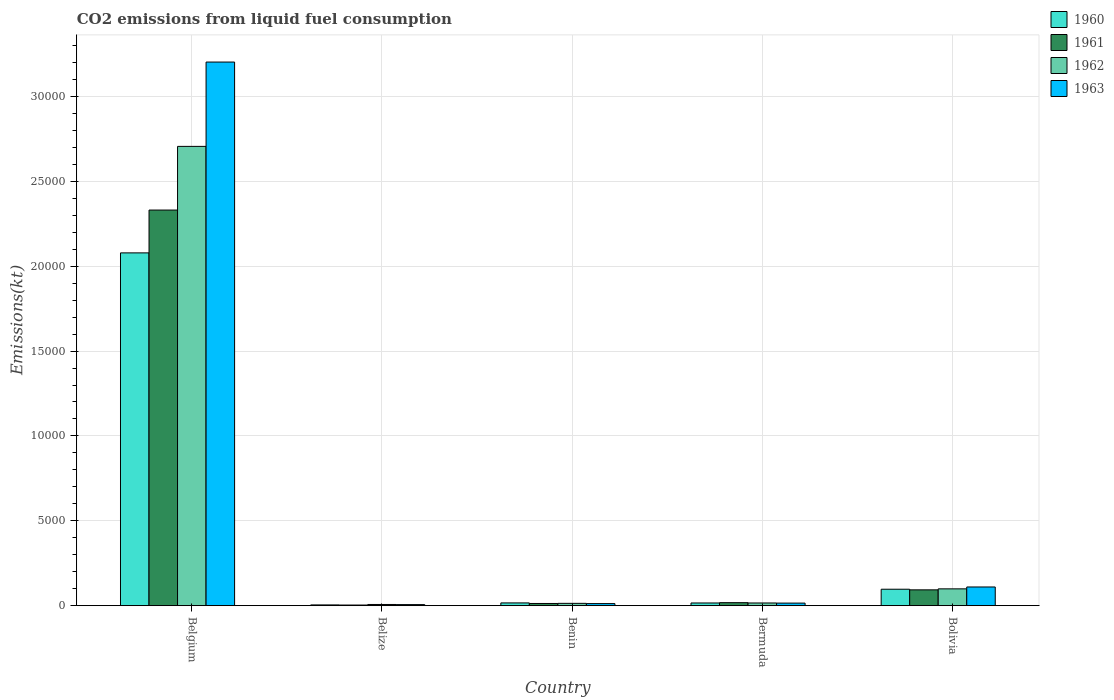Are the number of bars per tick equal to the number of legend labels?
Provide a short and direct response. Yes. Are the number of bars on each tick of the X-axis equal?
Your answer should be very brief. Yes. How many bars are there on the 4th tick from the left?
Ensure brevity in your answer.  4. What is the label of the 4th group of bars from the left?
Offer a terse response. Bermuda. In how many cases, is the number of bars for a given country not equal to the number of legend labels?
Give a very brief answer. 0. What is the amount of CO2 emitted in 1963 in Belgium?
Provide a short and direct response. 3.20e+04. Across all countries, what is the maximum amount of CO2 emitted in 1963?
Keep it short and to the point. 3.20e+04. Across all countries, what is the minimum amount of CO2 emitted in 1961?
Provide a short and direct response. 36.67. In which country was the amount of CO2 emitted in 1961 minimum?
Provide a short and direct response. Belize. What is the total amount of CO2 emitted in 1962 in the graph?
Offer a very short reply. 2.84e+04. What is the difference between the amount of CO2 emitted in 1962 in Belize and that in Bermuda?
Offer a very short reply. -88.01. What is the difference between the amount of CO2 emitted in 1960 in Belize and the amount of CO2 emitted in 1962 in Bolivia?
Make the answer very short. -946.09. What is the average amount of CO2 emitted in 1960 per country?
Provide a short and direct response. 4423.14. What is the difference between the amount of CO2 emitted of/in 1961 and amount of CO2 emitted of/in 1963 in Benin?
Provide a short and direct response. 7.33. In how many countries, is the amount of CO2 emitted in 1962 greater than 12000 kt?
Make the answer very short. 1. What is the ratio of the amount of CO2 emitted in 1961 in Benin to that in Bermuda?
Give a very brief answer. 0.73. Is the amount of CO2 emitted in 1960 in Belgium less than that in Benin?
Provide a short and direct response. No. Is the difference between the amount of CO2 emitted in 1961 in Belgium and Belize greater than the difference between the amount of CO2 emitted in 1963 in Belgium and Belize?
Your answer should be very brief. No. What is the difference between the highest and the second highest amount of CO2 emitted in 1960?
Keep it short and to the point. 2.06e+04. What is the difference between the highest and the lowest amount of CO2 emitted in 1962?
Your response must be concise. 2.70e+04. In how many countries, is the amount of CO2 emitted in 1961 greater than the average amount of CO2 emitted in 1961 taken over all countries?
Keep it short and to the point. 1. What does the 2nd bar from the right in Benin represents?
Make the answer very short. 1962. Is it the case that in every country, the sum of the amount of CO2 emitted in 1961 and amount of CO2 emitted in 1962 is greater than the amount of CO2 emitted in 1963?
Your answer should be compact. Yes. How many bars are there?
Offer a very short reply. 20. Does the graph contain any zero values?
Make the answer very short. No. Does the graph contain grids?
Your answer should be compact. Yes. Where does the legend appear in the graph?
Offer a very short reply. Top right. How many legend labels are there?
Your response must be concise. 4. How are the legend labels stacked?
Offer a very short reply. Vertical. What is the title of the graph?
Give a very brief answer. CO2 emissions from liquid fuel consumption. Does "1973" appear as one of the legend labels in the graph?
Your answer should be compact. No. What is the label or title of the X-axis?
Provide a succinct answer. Country. What is the label or title of the Y-axis?
Give a very brief answer. Emissions(kt). What is the Emissions(kt) in 1960 in Belgium?
Offer a very short reply. 2.08e+04. What is the Emissions(kt) in 1961 in Belgium?
Your response must be concise. 2.33e+04. What is the Emissions(kt) of 1962 in Belgium?
Your answer should be very brief. 2.71e+04. What is the Emissions(kt) in 1963 in Belgium?
Your answer should be very brief. 3.20e+04. What is the Emissions(kt) in 1960 in Belize?
Keep it short and to the point. 44. What is the Emissions(kt) of 1961 in Belize?
Make the answer very short. 36.67. What is the Emissions(kt) in 1962 in Belize?
Make the answer very short. 69.67. What is the Emissions(kt) in 1963 in Belize?
Offer a terse response. 62.34. What is the Emissions(kt) of 1960 in Benin?
Offer a terse response. 161.35. What is the Emissions(kt) of 1961 in Benin?
Provide a succinct answer. 128.34. What is the Emissions(kt) of 1962 in Benin?
Offer a very short reply. 135.68. What is the Emissions(kt) in 1963 in Benin?
Your response must be concise. 121.01. What is the Emissions(kt) of 1960 in Bermuda?
Your answer should be very brief. 157.68. What is the Emissions(kt) of 1961 in Bermuda?
Offer a very short reply. 176.02. What is the Emissions(kt) of 1962 in Bermuda?
Your answer should be compact. 157.68. What is the Emissions(kt) of 1963 in Bermuda?
Ensure brevity in your answer.  150.35. What is the Emissions(kt) in 1960 in Bolivia?
Give a very brief answer. 968.09. What is the Emissions(kt) in 1961 in Bolivia?
Offer a very short reply. 931.42. What is the Emissions(kt) in 1962 in Bolivia?
Your response must be concise. 990.09. What is the Emissions(kt) of 1963 in Bolivia?
Provide a short and direct response. 1100.1. Across all countries, what is the maximum Emissions(kt) of 1960?
Ensure brevity in your answer.  2.08e+04. Across all countries, what is the maximum Emissions(kt) of 1961?
Your answer should be compact. 2.33e+04. Across all countries, what is the maximum Emissions(kt) in 1962?
Give a very brief answer. 2.71e+04. Across all countries, what is the maximum Emissions(kt) in 1963?
Offer a very short reply. 3.20e+04. Across all countries, what is the minimum Emissions(kt) in 1960?
Offer a terse response. 44. Across all countries, what is the minimum Emissions(kt) in 1961?
Offer a very short reply. 36.67. Across all countries, what is the minimum Emissions(kt) in 1962?
Offer a terse response. 69.67. Across all countries, what is the minimum Emissions(kt) of 1963?
Your response must be concise. 62.34. What is the total Emissions(kt) in 1960 in the graph?
Your answer should be compact. 2.21e+04. What is the total Emissions(kt) of 1961 in the graph?
Keep it short and to the point. 2.46e+04. What is the total Emissions(kt) of 1962 in the graph?
Offer a terse response. 2.84e+04. What is the total Emissions(kt) in 1963 in the graph?
Your response must be concise. 3.35e+04. What is the difference between the Emissions(kt) in 1960 in Belgium and that in Belize?
Your response must be concise. 2.07e+04. What is the difference between the Emissions(kt) of 1961 in Belgium and that in Belize?
Your answer should be compact. 2.33e+04. What is the difference between the Emissions(kt) in 1962 in Belgium and that in Belize?
Ensure brevity in your answer.  2.70e+04. What is the difference between the Emissions(kt) in 1963 in Belgium and that in Belize?
Your answer should be very brief. 3.20e+04. What is the difference between the Emissions(kt) of 1960 in Belgium and that in Benin?
Give a very brief answer. 2.06e+04. What is the difference between the Emissions(kt) of 1961 in Belgium and that in Benin?
Offer a very short reply. 2.32e+04. What is the difference between the Emissions(kt) in 1962 in Belgium and that in Benin?
Your response must be concise. 2.69e+04. What is the difference between the Emissions(kt) in 1963 in Belgium and that in Benin?
Provide a succinct answer. 3.19e+04. What is the difference between the Emissions(kt) of 1960 in Belgium and that in Bermuda?
Make the answer very short. 2.06e+04. What is the difference between the Emissions(kt) of 1961 in Belgium and that in Bermuda?
Provide a short and direct response. 2.31e+04. What is the difference between the Emissions(kt) of 1962 in Belgium and that in Bermuda?
Your answer should be very brief. 2.69e+04. What is the difference between the Emissions(kt) of 1963 in Belgium and that in Bermuda?
Your response must be concise. 3.19e+04. What is the difference between the Emissions(kt) of 1960 in Belgium and that in Bolivia?
Provide a succinct answer. 1.98e+04. What is the difference between the Emissions(kt) of 1961 in Belgium and that in Bolivia?
Provide a short and direct response. 2.24e+04. What is the difference between the Emissions(kt) in 1962 in Belgium and that in Bolivia?
Your answer should be very brief. 2.61e+04. What is the difference between the Emissions(kt) of 1963 in Belgium and that in Bolivia?
Provide a succinct answer. 3.09e+04. What is the difference between the Emissions(kt) in 1960 in Belize and that in Benin?
Offer a very short reply. -117.34. What is the difference between the Emissions(kt) in 1961 in Belize and that in Benin?
Your answer should be compact. -91.67. What is the difference between the Emissions(kt) of 1962 in Belize and that in Benin?
Offer a terse response. -66.01. What is the difference between the Emissions(kt) in 1963 in Belize and that in Benin?
Give a very brief answer. -58.67. What is the difference between the Emissions(kt) of 1960 in Belize and that in Bermuda?
Offer a terse response. -113.68. What is the difference between the Emissions(kt) of 1961 in Belize and that in Bermuda?
Provide a succinct answer. -139.35. What is the difference between the Emissions(kt) in 1962 in Belize and that in Bermuda?
Ensure brevity in your answer.  -88.01. What is the difference between the Emissions(kt) of 1963 in Belize and that in Bermuda?
Provide a succinct answer. -88.01. What is the difference between the Emissions(kt) of 1960 in Belize and that in Bolivia?
Provide a short and direct response. -924.08. What is the difference between the Emissions(kt) in 1961 in Belize and that in Bolivia?
Give a very brief answer. -894.75. What is the difference between the Emissions(kt) of 1962 in Belize and that in Bolivia?
Ensure brevity in your answer.  -920.42. What is the difference between the Emissions(kt) of 1963 in Belize and that in Bolivia?
Ensure brevity in your answer.  -1037.76. What is the difference between the Emissions(kt) in 1960 in Benin and that in Bermuda?
Your answer should be compact. 3.67. What is the difference between the Emissions(kt) of 1961 in Benin and that in Bermuda?
Give a very brief answer. -47.67. What is the difference between the Emissions(kt) in 1962 in Benin and that in Bermuda?
Your answer should be very brief. -22. What is the difference between the Emissions(kt) of 1963 in Benin and that in Bermuda?
Provide a short and direct response. -29.34. What is the difference between the Emissions(kt) of 1960 in Benin and that in Bolivia?
Offer a terse response. -806.74. What is the difference between the Emissions(kt) of 1961 in Benin and that in Bolivia?
Give a very brief answer. -803.07. What is the difference between the Emissions(kt) in 1962 in Benin and that in Bolivia?
Make the answer very short. -854.41. What is the difference between the Emissions(kt) of 1963 in Benin and that in Bolivia?
Your response must be concise. -979.09. What is the difference between the Emissions(kt) of 1960 in Bermuda and that in Bolivia?
Keep it short and to the point. -810.41. What is the difference between the Emissions(kt) in 1961 in Bermuda and that in Bolivia?
Your response must be concise. -755.4. What is the difference between the Emissions(kt) in 1962 in Bermuda and that in Bolivia?
Your answer should be compact. -832.41. What is the difference between the Emissions(kt) of 1963 in Bermuda and that in Bolivia?
Provide a succinct answer. -949.75. What is the difference between the Emissions(kt) of 1960 in Belgium and the Emissions(kt) of 1961 in Belize?
Provide a short and direct response. 2.07e+04. What is the difference between the Emissions(kt) in 1960 in Belgium and the Emissions(kt) in 1962 in Belize?
Offer a terse response. 2.07e+04. What is the difference between the Emissions(kt) of 1960 in Belgium and the Emissions(kt) of 1963 in Belize?
Give a very brief answer. 2.07e+04. What is the difference between the Emissions(kt) in 1961 in Belgium and the Emissions(kt) in 1962 in Belize?
Offer a very short reply. 2.32e+04. What is the difference between the Emissions(kt) in 1961 in Belgium and the Emissions(kt) in 1963 in Belize?
Ensure brevity in your answer.  2.32e+04. What is the difference between the Emissions(kt) of 1962 in Belgium and the Emissions(kt) of 1963 in Belize?
Your answer should be very brief. 2.70e+04. What is the difference between the Emissions(kt) of 1960 in Belgium and the Emissions(kt) of 1961 in Benin?
Offer a very short reply. 2.07e+04. What is the difference between the Emissions(kt) of 1960 in Belgium and the Emissions(kt) of 1962 in Benin?
Your answer should be compact. 2.06e+04. What is the difference between the Emissions(kt) in 1960 in Belgium and the Emissions(kt) in 1963 in Benin?
Ensure brevity in your answer.  2.07e+04. What is the difference between the Emissions(kt) of 1961 in Belgium and the Emissions(kt) of 1962 in Benin?
Your answer should be compact. 2.32e+04. What is the difference between the Emissions(kt) in 1961 in Belgium and the Emissions(kt) in 1963 in Benin?
Give a very brief answer. 2.32e+04. What is the difference between the Emissions(kt) in 1962 in Belgium and the Emissions(kt) in 1963 in Benin?
Provide a succinct answer. 2.69e+04. What is the difference between the Emissions(kt) in 1960 in Belgium and the Emissions(kt) in 1961 in Bermuda?
Provide a short and direct response. 2.06e+04. What is the difference between the Emissions(kt) in 1960 in Belgium and the Emissions(kt) in 1962 in Bermuda?
Provide a short and direct response. 2.06e+04. What is the difference between the Emissions(kt) of 1960 in Belgium and the Emissions(kt) of 1963 in Bermuda?
Provide a short and direct response. 2.06e+04. What is the difference between the Emissions(kt) of 1961 in Belgium and the Emissions(kt) of 1962 in Bermuda?
Your response must be concise. 2.31e+04. What is the difference between the Emissions(kt) in 1961 in Belgium and the Emissions(kt) in 1963 in Bermuda?
Your answer should be compact. 2.32e+04. What is the difference between the Emissions(kt) of 1962 in Belgium and the Emissions(kt) of 1963 in Bermuda?
Keep it short and to the point. 2.69e+04. What is the difference between the Emissions(kt) of 1960 in Belgium and the Emissions(kt) of 1961 in Bolivia?
Provide a short and direct response. 1.99e+04. What is the difference between the Emissions(kt) in 1960 in Belgium and the Emissions(kt) in 1962 in Bolivia?
Provide a succinct answer. 1.98e+04. What is the difference between the Emissions(kt) of 1960 in Belgium and the Emissions(kt) of 1963 in Bolivia?
Provide a short and direct response. 1.97e+04. What is the difference between the Emissions(kt) of 1961 in Belgium and the Emissions(kt) of 1962 in Bolivia?
Keep it short and to the point. 2.23e+04. What is the difference between the Emissions(kt) in 1961 in Belgium and the Emissions(kt) in 1963 in Bolivia?
Ensure brevity in your answer.  2.22e+04. What is the difference between the Emissions(kt) in 1962 in Belgium and the Emissions(kt) in 1963 in Bolivia?
Keep it short and to the point. 2.60e+04. What is the difference between the Emissions(kt) in 1960 in Belize and the Emissions(kt) in 1961 in Benin?
Offer a very short reply. -84.34. What is the difference between the Emissions(kt) in 1960 in Belize and the Emissions(kt) in 1962 in Benin?
Your answer should be very brief. -91.67. What is the difference between the Emissions(kt) in 1960 in Belize and the Emissions(kt) in 1963 in Benin?
Your response must be concise. -77.01. What is the difference between the Emissions(kt) of 1961 in Belize and the Emissions(kt) of 1962 in Benin?
Make the answer very short. -99.01. What is the difference between the Emissions(kt) of 1961 in Belize and the Emissions(kt) of 1963 in Benin?
Make the answer very short. -84.34. What is the difference between the Emissions(kt) of 1962 in Belize and the Emissions(kt) of 1963 in Benin?
Your response must be concise. -51.34. What is the difference between the Emissions(kt) of 1960 in Belize and the Emissions(kt) of 1961 in Bermuda?
Make the answer very short. -132.01. What is the difference between the Emissions(kt) of 1960 in Belize and the Emissions(kt) of 1962 in Bermuda?
Provide a short and direct response. -113.68. What is the difference between the Emissions(kt) in 1960 in Belize and the Emissions(kt) in 1963 in Bermuda?
Ensure brevity in your answer.  -106.34. What is the difference between the Emissions(kt) of 1961 in Belize and the Emissions(kt) of 1962 in Bermuda?
Make the answer very short. -121.01. What is the difference between the Emissions(kt) in 1961 in Belize and the Emissions(kt) in 1963 in Bermuda?
Offer a very short reply. -113.68. What is the difference between the Emissions(kt) of 1962 in Belize and the Emissions(kt) of 1963 in Bermuda?
Ensure brevity in your answer.  -80.67. What is the difference between the Emissions(kt) in 1960 in Belize and the Emissions(kt) in 1961 in Bolivia?
Make the answer very short. -887.41. What is the difference between the Emissions(kt) in 1960 in Belize and the Emissions(kt) in 1962 in Bolivia?
Provide a succinct answer. -946.09. What is the difference between the Emissions(kt) of 1960 in Belize and the Emissions(kt) of 1963 in Bolivia?
Provide a short and direct response. -1056.1. What is the difference between the Emissions(kt) of 1961 in Belize and the Emissions(kt) of 1962 in Bolivia?
Make the answer very short. -953.42. What is the difference between the Emissions(kt) of 1961 in Belize and the Emissions(kt) of 1963 in Bolivia?
Your answer should be very brief. -1063.43. What is the difference between the Emissions(kt) in 1962 in Belize and the Emissions(kt) in 1963 in Bolivia?
Your response must be concise. -1030.43. What is the difference between the Emissions(kt) in 1960 in Benin and the Emissions(kt) in 1961 in Bermuda?
Give a very brief answer. -14.67. What is the difference between the Emissions(kt) in 1960 in Benin and the Emissions(kt) in 1962 in Bermuda?
Give a very brief answer. 3.67. What is the difference between the Emissions(kt) in 1960 in Benin and the Emissions(kt) in 1963 in Bermuda?
Ensure brevity in your answer.  11. What is the difference between the Emissions(kt) of 1961 in Benin and the Emissions(kt) of 1962 in Bermuda?
Your answer should be compact. -29.34. What is the difference between the Emissions(kt) in 1961 in Benin and the Emissions(kt) in 1963 in Bermuda?
Make the answer very short. -22. What is the difference between the Emissions(kt) of 1962 in Benin and the Emissions(kt) of 1963 in Bermuda?
Provide a succinct answer. -14.67. What is the difference between the Emissions(kt) in 1960 in Benin and the Emissions(kt) in 1961 in Bolivia?
Provide a succinct answer. -770.07. What is the difference between the Emissions(kt) in 1960 in Benin and the Emissions(kt) in 1962 in Bolivia?
Provide a succinct answer. -828.74. What is the difference between the Emissions(kt) of 1960 in Benin and the Emissions(kt) of 1963 in Bolivia?
Ensure brevity in your answer.  -938.75. What is the difference between the Emissions(kt) of 1961 in Benin and the Emissions(kt) of 1962 in Bolivia?
Your answer should be compact. -861.75. What is the difference between the Emissions(kt) of 1961 in Benin and the Emissions(kt) of 1963 in Bolivia?
Offer a very short reply. -971.75. What is the difference between the Emissions(kt) of 1962 in Benin and the Emissions(kt) of 1963 in Bolivia?
Ensure brevity in your answer.  -964.42. What is the difference between the Emissions(kt) of 1960 in Bermuda and the Emissions(kt) of 1961 in Bolivia?
Your answer should be compact. -773.74. What is the difference between the Emissions(kt) of 1960 in Bermuda and the Emissions(kt) of 1962 in Bolivia?
Give a very brief answer. -832.41. What is the difference between the Emissions(kt) in 1960 in Bermuda and the Emissions(kt) in 1963 in Bolivia?
Offer a very short reply. -942.42. What is the difference between the Emissions(kt) of 1961 in Bermuda and the Emissions(kt) of 1962 in Bolivia?
Offer a very short reply. -814.07. What is the difference between the Emissions(kt) in 1961 in Bermuda and the Emissions(kt) in 1963 in Bolivia?
Your answer should be compact. -924.08. What is the difference between the Emissions(kt) of 1962 in Bermuda and the Emissions(kt) of 1963 in Bolivia?
Ensure brevity in your answer.  -942.42. What is the average Emissions(kt) of 1960 per country?
Provide a short and direct response. 4423.14. What is the average Emissions(kt) in 1961 per country?
Your response must be concise. 4915.98. What is the average Emissions(kt) in 1962 per country?
Keep it short and to the point. 5682.38. What is the average Emissions(kt) of 1963 per country?
Provide a short and direct response. 6692.27. What is the difference between the Emissions(kt) in 1960 and Emissions(kt) in 1961 in Belgium?
Make the answer very short. -2522.9. What is the difference between the Emissions(kt) in 1960 and Emissions(kt) in 1962 in Belgium?
Make the answer very short. -6274.24. What is the difference between the Emissions(kt) of 1960 and Emissions(kt) of 1963 in Belgium?
Ensure brevity in your answer.  -1.12e+04. What is the difference between the Emissions(kt) of 1961 and Emissions(kt) of 1962 in Belgium?
Provide a succinct answer. -3751.34. What is the difference between the Emissions(kt) in 1961 and Emissions(kt) in 1963 in Belgium?
Provide a succinct answer. -8720.13. What is the difference between the Emissions(kt) of 1962 and Emissions(kt) of 1963 in Belgium?
Keep it short and to the point. -4968.78. What is the difference between the Emissions(kt) of 1960 and Emissions(kt) of 1961 in Belize?
Provide a succinct answer. 7.33. What is the difference between the Emissions(kt) in 1960 and Emissions(kt) in 1962 in Belize?
Ensure brevity in your answer.  -25.67. What is the difference between the Emissions(kt) of 1960 and Emissions(kt) of 1963 in Belize?
Give a very brief answer. -18.34. What is the difference between the Emissions(kt) of 1961 and Emissions(kt) of 1962 in Belize?
Ensure brevity in your answer.  -33. What is the difference between the Emissions(kt) in 1961 and Emissions(kt) in 1963 in Belize?
Your answer should be very brief. -25.67. What is the difference between the Emissions(kt) of 1962 and Emissions(kt) of 1963 in Belize?
Make the answer very short. 7.33. What is the difference between the Emissions(kt) of 1960 and Emissions(kt) of 1961 in Benin?
Your answer should be very brief. 33. What is the difference between the Emissions(kt) of 1960 and Emissions(kt) of 1962 in Benin?
Your response must be concise. 25.67. What is the difference between the Emissions(kt) in 1960 and Emissions(kt) in 1963 in Benin?
Provide a succinct answer. 40.34. What is the difference between the Emissions(kt) of 1961 and Emissions(kt) of 1962 in Benin?
Your answer should be very brief. -7.33. What is the difference between the Emissions(kt) of 1961 and Emissions(kt) of 1963 in Benin?
Ensure brevity in your answer.  7.33. What is the difference between the Emissions(kt) in 1962 and Emissions(kt) in 1963 in Benin?
Ensure brevity in your answer.  14.67. What is the difference between the Emissions(kt) of 1960 and Emissions(kt) of 1961 in Bermuda?
Offer a terse response. -18.34. What is the difference between the Emissions(kt) of 1960 and Emissions(kt) of 1962 in Bermuda?
Your response must be concise. 0. What is the difference between the Emissions(kt) of 1960 and Emissions(kt) of 1963 in Bermuda?
Offer a very short reply. 7.33. What is the difference between the Emissions(kt) in 1961 and Emissions(kt) in 1962 in Bermuda?
Your response must be concise. 18.34. What is the difference between the Emissions(kt) of 1961 and Emissions(kt) of 1963 in Bermuda?
Your response must be concise. 25.67. What is the difference between the Emissions(kt) of 1962 and Emissions(kt) of 1963 in Bermuda?
Provide a short and direct response. 7.33. What is the difference between the Emissions(kt) in 1960 and Emissions(kt) in 1961 in Bolivia?
Offer a terse response. 36.67. What is the difference between the Emissions(kt) of 1960 and Emissions(kt) of 1962 in Bolivia?
Keep it short and to the point. -22. What is the difference between the Emissions(kt) in 1960 and Emissions(kt) in 1963 in Bolivia?
Ensure brevity in your answer.  -132.01. What is the difference between the Emissions(kt) of 1961 and Emissions(kt) of 1962 in Bolivia?
Ensure brevity in your answer.  -58.67. What is the difference between the Emissions(kt) in 1961 and Emissions(kt) in 1963 in Bolivia?
Provide a succinct answer. -168.68. What is the difference between the Emissions(kt) of 1962 and Emissions(kt) of 1963 in Bolivia?
Your response must be concise. -110.01. What is the ratio of the Emissions(kt) in 1960 in Belgium to that in Belize?
Your response must be concise. 472.33. What is the ratio of the Emissions(kt) of 1961 in Belgium to that in Belize?
Provide a short and direct response. 635.6. What is the ratio of the Emissions(kt) of 1962 in Belgium to that in Belize?
Make the answer very short. 388.37. What is the ratio of the Emissions(kt) of 1963 in Belgium to that in Belize?
Your answer should be very brief. 513.76. What is the ratio of the Emissions(kt) in 1960 in Belgium to that in Benin?
Keep it short and to the point. 128.82. What is the ratio of the Emissions(kt) in 1961 in Belgium to that in Benin?
Your response must be concise. 181.6. What is the ratio of the Emissions(kt) of 1962 in Belgium to that in Benin?
Your response must be concise. 199.43. What is the ratio of the Emissions(kt) of 1963 in Belgium to that in Benin?
Provide a succinct answer. 264.67. What is the ratio of the Emissions(kt) of 1960 in Belgium to that in Bermuda?
Make the answer very short. 131.81. What is the ratio of the Emissions(kt) in 1961 in Belgium to that in Bermuda?
Make the answer very short. 132.42. What is the ratio of the Emissions(kt) in 1962 in Belgium to that in Bermuda?
Offer a very short reply. 171.6. What is the ratio of the Emissions(kt) of 1963 in Belgium to that in Bermuda?
Keep it short and to the point. 213.02. What is the ratio of the Emissions(kt) in 1960 in Belgium to that in Bolivia?
Provide a succinct answer. 21.47. What is the ratio of the Emissions(kt) of 1961 in Belgium to that in Bolivia?
Your response must be concise. 25.02. What is the ratio of the Emissions(kt) in 1962 in Belgium to that in Bolivia?
Your answer should be very brief. 27.33. What is the ratio of the Emissions(kt) of 1963 in Belgium to that in Bolivia?
Your answer should be very brief. 29.11. What is the ratio of the Emissions(kt) in 1960 in Belize to that in Benin?
Your response must be concise. 0.27. What is the ratio of the Emissions(kt) of 1961 in Belize to that in Benin?
Make the answer very short. 0.29. What is the ratio of the Emissions(kt) in 1962 in Belize to that in Benin?
Your answer should be compact. 0.51. What is the ratio of the Emissions(kt) of 1963 in Belize to that in Benin?
Give a very brief answer. 0.52. What is the ratio of the Emissions(kt) of 1960 in Belize to that in Bermuda?
Give a very brief answer. 0.28. What is the ratio of the Emissions(kt) in 1961 in Belize to that in Bermuda?
Your answer should be compact. 0.21. What is the ratio of the Emissions(kt) in 1962 in Belize to that in Bermuda?
Offer a very short reply. 0.44. What is the ratio of the Emissions(kt) of 1963 in Belize to that in Bermuda?
Your answer should be compact. 0.41. What is the ratio of the Emissions(kt) of 1960 in Belize to that in Bolivia?
Your answer should be compact. 0.05. What is the ratio of the Emissions(kt) of 1961 in Belize to that in Bolivia?
Your answer should be very brief. 0.04. What is the ratio of the Emissions(kt) of 1962 in Belize to that in Bolivia?
Provide a succinct answer. 0.07. What is the ratio of the Emissions(kt) in 1963 in Belize to that in Bolivia?
Make the answer very short. 0.06. What is the ratio of the Emissions(kt) in 1960 in Benin to that in Bermuda?
Give a very brief answer. 1.02. What is the ratio of the Emissions(kt) of 1961 in Benin to that in Bermuda?
Provide a short and direct response. 0.73. What is the ratio of the Emissions(kt) in 1962 in Benin to that in Bermuda?
Your answer should be compact. 0.86. What is the ratio of the Emissions(kt) of 1963 in Benin to that in Bermuda?
Your response must be concise. 0.8. What is the ratio of the Emissions(kt) in 1961 in Benin to that in Bolivia?
Make the answer very short. 0.14. What is the ratio of the Emissions(kt) of 1962 in Benin to that in Bolivia?
Offer a very short reply. 0.14. What is the ratio of the Emissions(kt) in 1963 in Benin to that in Bolivia?
Ensure brevity in your answer.  0.11. What is the ratio of the Emissions(kt) of 1960 in Bermuda to that in Bolivia?
Your answer should be very brief. 0.16. What is the ratio of the Emissions(kt) of 1961 in Bermuda to that in Bolivia?
Offer a very short reply. 0.19. What is the ratio of the Emissions(kt) of 1962 in Bermuda to that in Bolivia?
Offer a very short reply. 0.16. What is the ratio of the Emissions(kt) of 1963 in Bermuda to that in Bolivia?
Provide a succinct answer. 0.14. What is the difference between the highest and the second highest Emissions(kt) in 1960?
Your answer should be compact. 1.98e+04. What is the difference between the highest and the second highest Emissions(kt) of 1961?
Provide a succinct answer. 2.24e+04. What is the difference between the highest and the second highest Emissions(kt) of 1962?
Your response must be concise. 2.61e+04. What is the difference between the highest and the second highest Emissions(kt) in 1963?
Provide a succinct answer. 3.09e+04. What is the difference between the highest and the lowest Emissions(kt) of 1960?
Give a very brief answer. 2.07e+04. What is the difference between the highest and the lowest Emissions(kt) in 1961?
Your response must be concise. 2.33e+04. What is the difference between the highest and the lowest Emissions(kt) of 1962?
Provide a short and direct response. 2.70e+04. What is the difference between the highest and the lowest Emissions(kt) of 1963?
Offer a very short reply. 3.20e+04. 